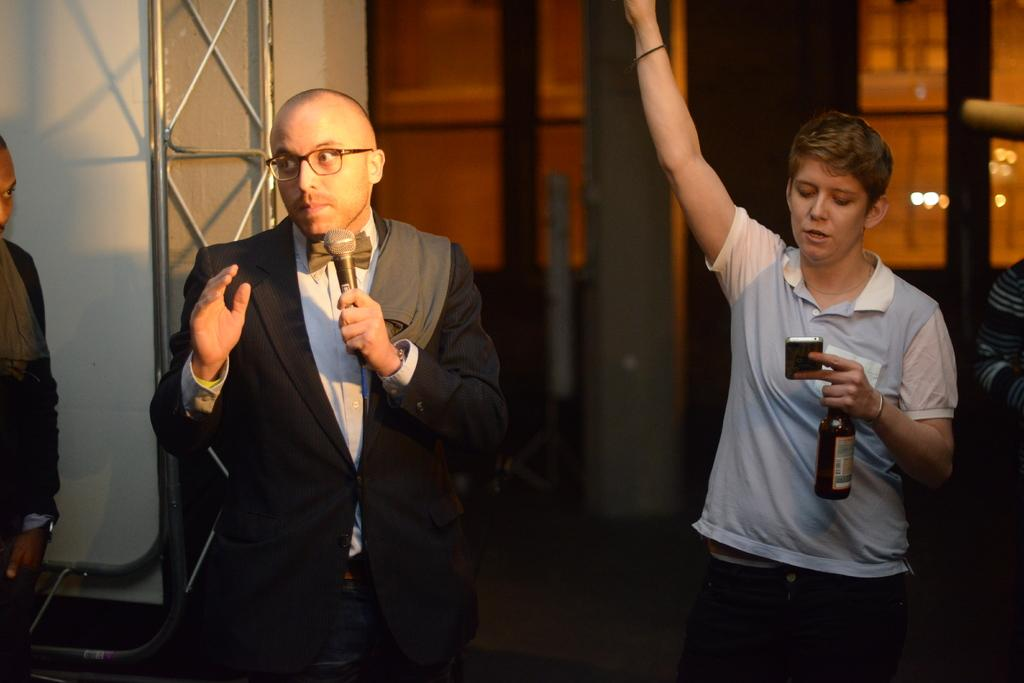How many men are in the image? There are two men in the image. What are the men doing in the image? The men are standing. What objects are the men holding? One man is holding a microphone, and the other man is holding a wine bottle. Are there any other people visible in the image? Yes, there are people standing in the corner of the image. What type of glass is being used to amplify the sound in the image? There is no glass being used to amplify sound in the image; one man is holding a microphone. 